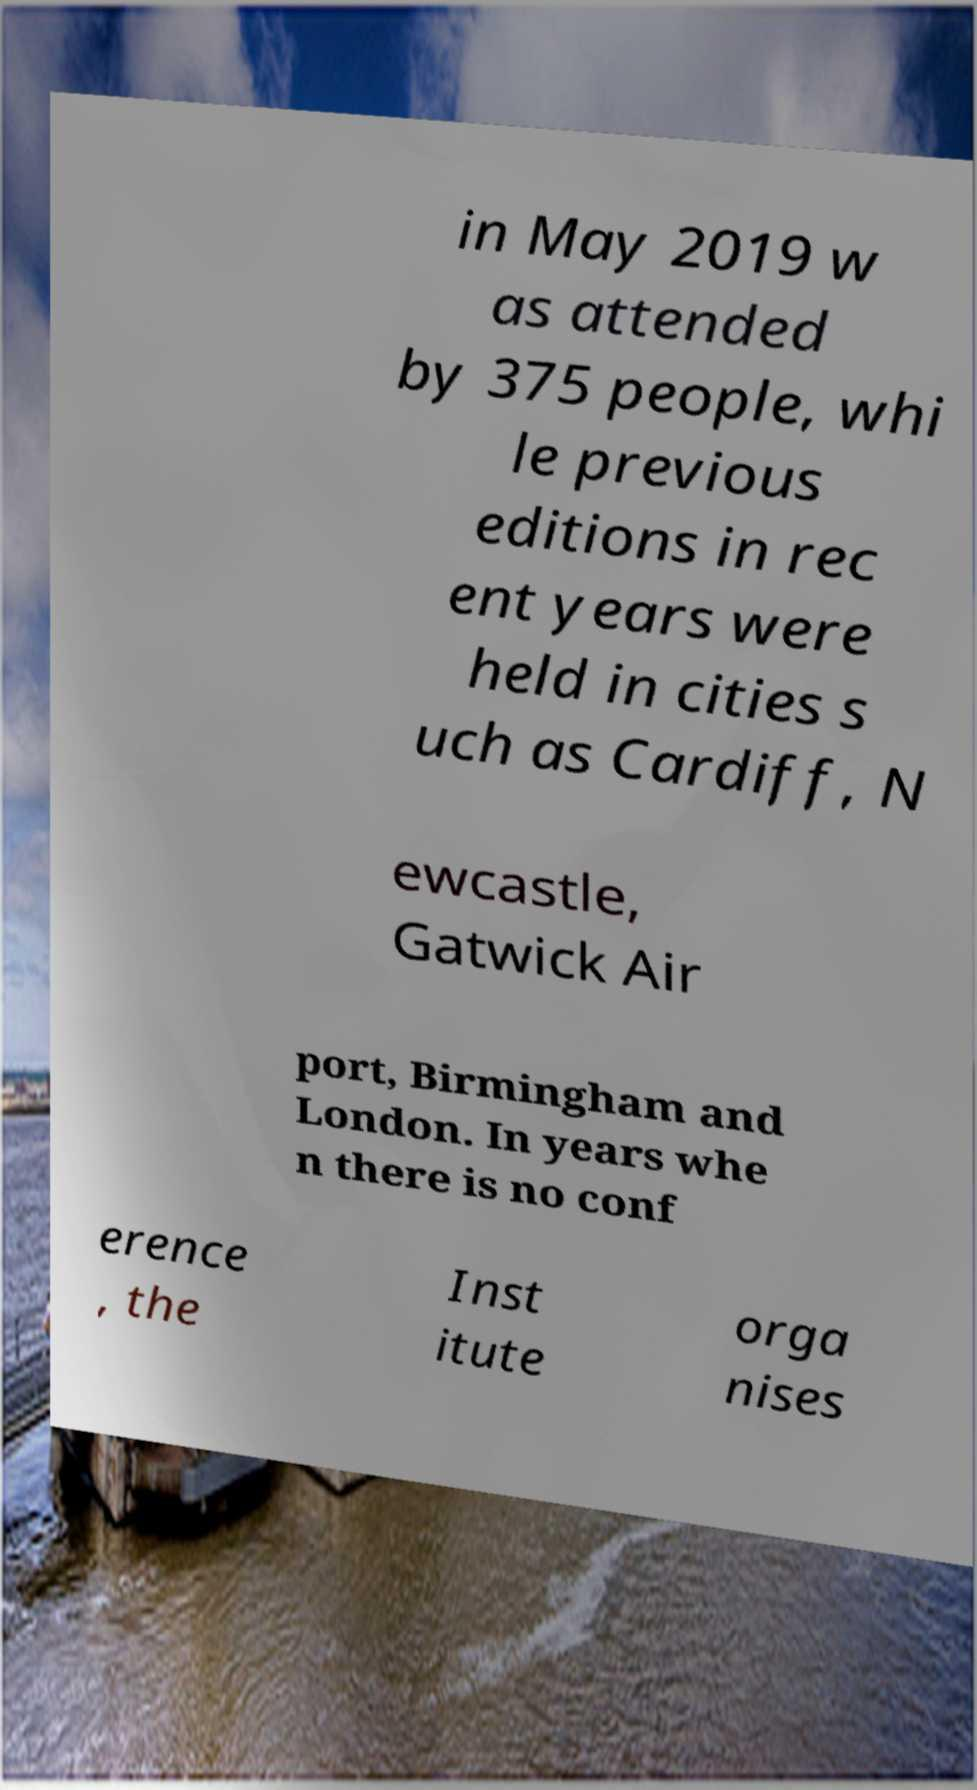There's text embedded in this image that I need extracted. Can you transcribe it verbatim? in May 2019 w as attended by 375 people, whi le previous editions in rec ent years were held in cities s uch as Cardiff, N ewcastle, Gatwick Air port, Birmingham and London. In years whe n there is no conf erence , the Inst itute orga nises 